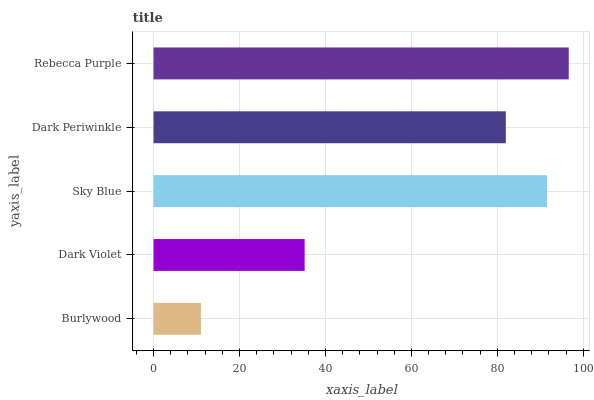Is Burlywood the minimum?
Answer yes or no. Yes. Is Rebecca Purple the maximum?
Answer yes or no. Yes. Is Dark Violet the minimum?
Answer yes or no. No. Is Dark Violet the maximum?
Answer yes or no. No. Is Dark Violet greater than Burlywood?
Answer yes or no. Yes. Is Burlywood less than Dark Violet?
Answer yes or no. Yes. Is Burlywood greater than Dark Violet?
Answer yes or no. No. Is Dark Violet less than Burlywood?
Answer yes or no. No. Is Dark Periwinkle the high median?
Answer yes or no. Yes. Is Dark Periwinkle the low median?
Answer yes or no. Yes. Is Rebecca Purple the high median?
Answer yes or no. No. Is Rebecca Purple the low median?
Answer yes or no. No. 